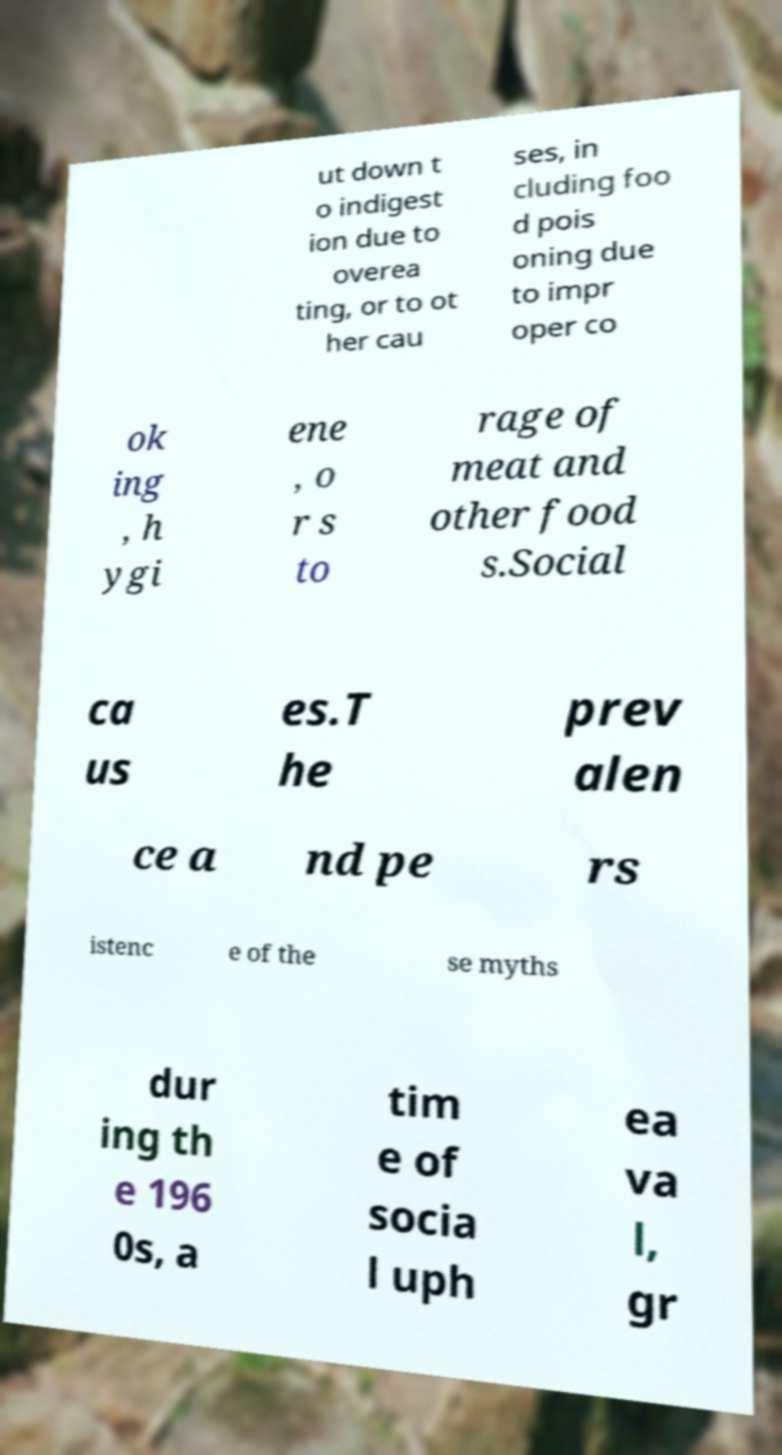Can you accurately transcribe the text from the provided image for me? ut down t o indigest ion due to overea ting, or to ot her cau ses, in cluding foo d pois oning due to impr oper co ok ing , h ygi ene , o r s to rage of meat and other food s.Social ca us es.T he prev alen ce a nd pe rs istenc e of the se myths dur ing th e 196 0s, a tim e of socia l uph ea va l, gr 